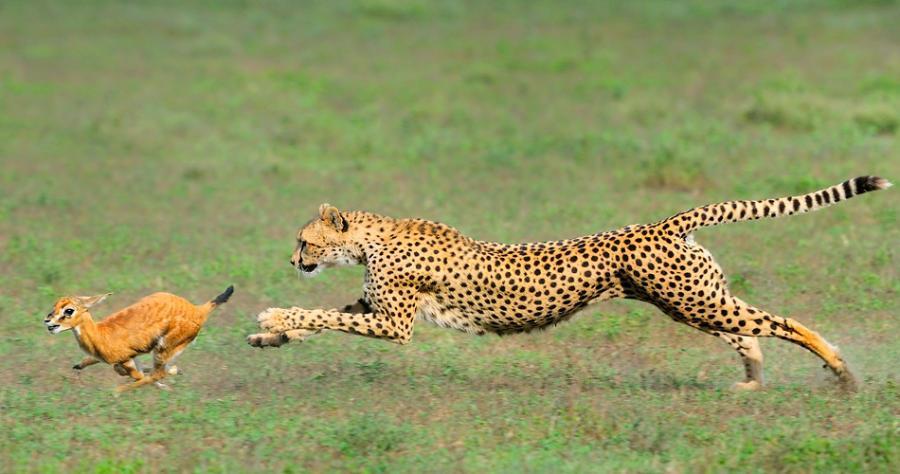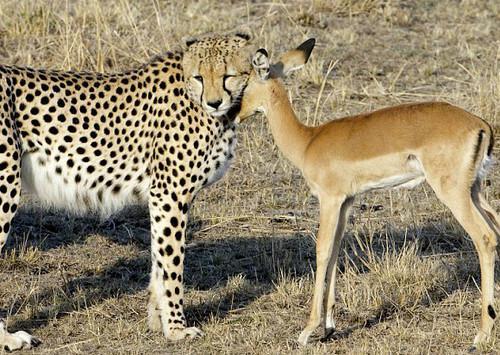The first image is the image on the left, the second image is the image on the right. For the images displayed, is the sentence "One of the large cats is biting an antelope." factually correct? Answer yes or no. No. The first image is the image on the left, the second image is the image on the right. Considering the images on both sides, is "The image on the left contains at least one cheetah eating an antelope." valid? Answer yes or no. No. 